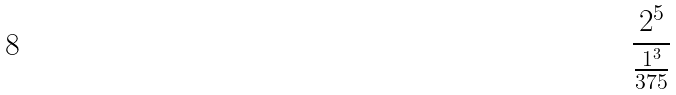Convert formula to latex. <formula><loc_0><loc_0><loc_500><loc_500>\frac { 2 ^ { 5 } } { \frac { 1 ^ { 3 } } { 3 7 5 } }</formula> 